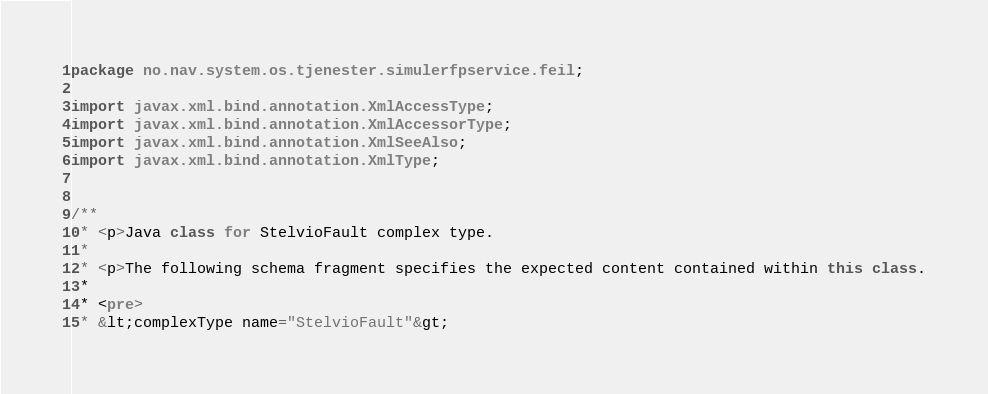<code> <loc_0><loc_0><loc_500><loc_500><_Java_>
package no.nav.system.os.tjenester.simulerfpservice.feil;

import javax.xml.bind.annotation.XmlAccessType;
import javax.xml.bind.annotation.XmlAccessorType;
import javax.xml.bind.annotation.XmlSeeAlso;
import javax.xml.bind.annotation.XmlType;


/**
 * <p>Java class for StelvioFault complex type.
 * 
 * <p>The following schema fragment specifies the expected content contained within this class.
 * 
 * <pre>
 * &lt;complexType name="StelvioFault"&gt;</code> 